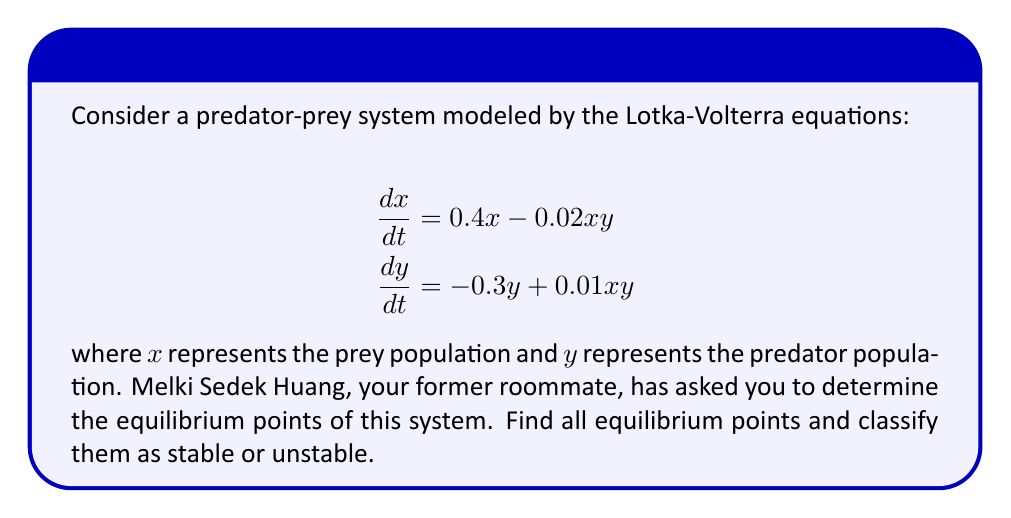Give your solution to this math problem. To solve this problem, we'll follow these steps:

1) Find the equilibrium points by setting both equations equal to zero and solving for x and y.
2) Analyze the stability of each equilibrium point using the Jacobian matrix.

Step 1: Finding equilibrium points

Set both equations to zero:

$$0.4x - 0.02xy = 0$$
$$-0.3y + 0.01xy = 0$$

From the first equation:
$$x(0.4 - 0.02y) = 0$$
This gives us $x = 0$ or $y = 20$

From the second equation:
$$y(-0.3 + 0.01x) = 0$$
This gives us $y = 0$ or $x = 30$

Combining these results, we get two equilibrium points:
(0, 0) and (30, 20)

Step 2: Analyzing stability

To analyze stability, we need to find the Jacobian matrix:

$$J = \begin{bmatrix}
\frac{\partial}{\partial x}(0.4x - 0.02xy) & \frac{\partial}{\partial y}(0.4x - 0.02xy) \\
\frac{\partial}{\partial x}(-0.3y + 0.01xy) & \frac{\partial}{\partial y}(-0.3y + 0.01xy)
\end{bmatrix}$$

$$J = \begin{bmatrix}
0.4 - 0.02y & -0.02x \\
0.01y & -0.3 + 0.01x
\end{bmatrix}$$

For (0, 0):
$$J_{(0,0)} = \begin{bmatrix}
0.4 & 0 \\
0 & -0.3
\end{bmatrix}$$

The eigenvalues are 0.4 and -0.3. Since one is positive, this equilibrium point is unstable.

For (30, 20):
$$J_{(30,20)} = \begin{bmatrix}
0 & -0.6 \\
0.2 & 0
\end{bmatrix}$$

The eigenvalues are $\pm i\sqrt{0.12}$. Since they are purely imaginary, this equilibrium point is neutrally stable (center).
Answer: The system has two equilibrium points: (0, 0) and (30, 20). The point (0, 0) is unstable, while (30, 20) is neutrally stable (center). 